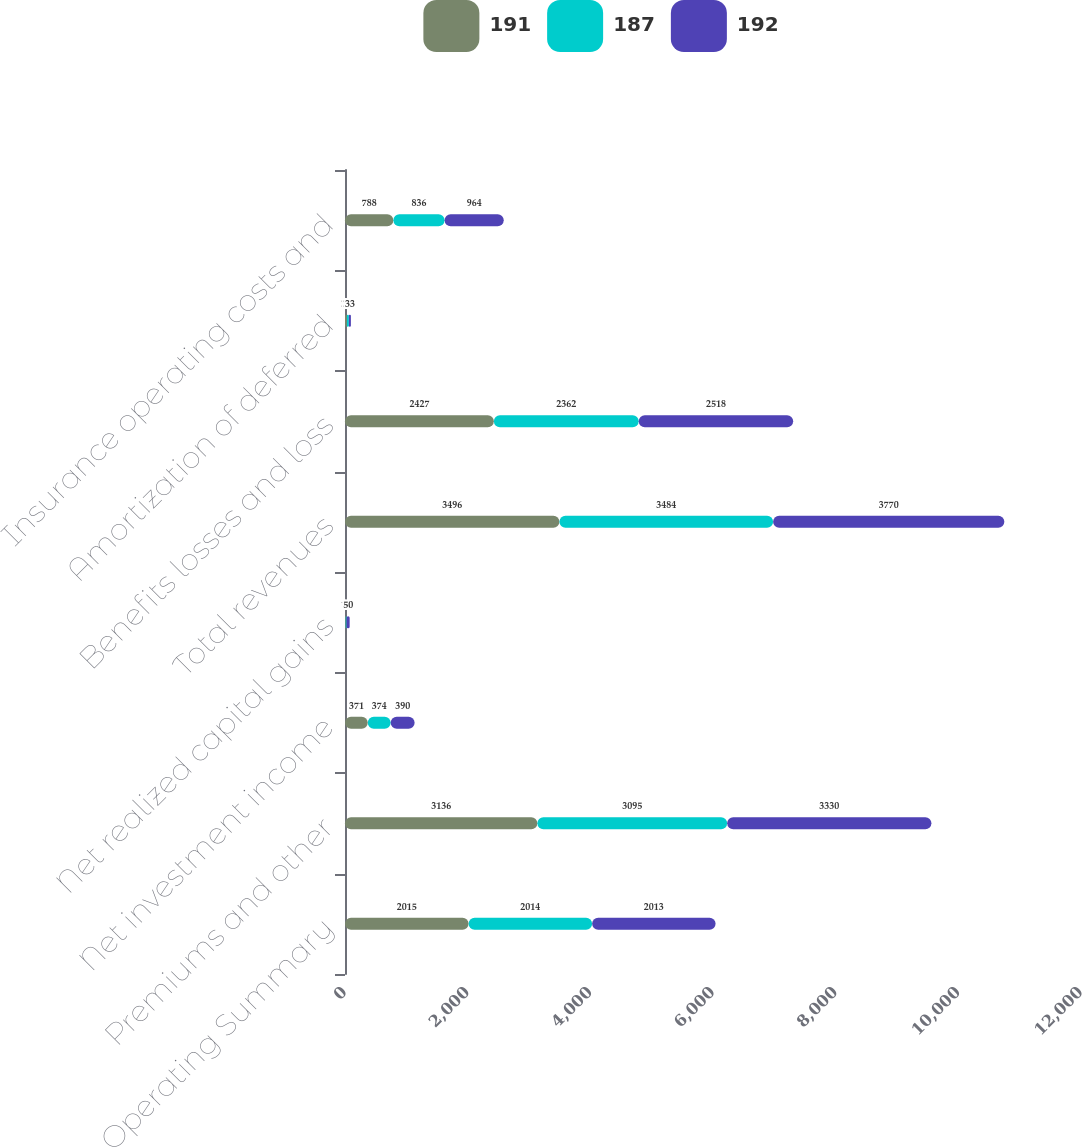Convert chart. <chart><loc_0><loc_0><loc_500><loc_500><stacked_bar_chart><ecel><fcel>Operating Summary<fcel>Premiums and other<fcel>Net investment income<fcel>Net realized capital gains<fcel>Total revenues<fcel>Benefits losses and loss<fcel>Amortization of deferred<fcel>Insurance operating costs and<nl><fcel>191<fcel>2015<fcel>3136<fcel>371<fcel>11<fcel>3496<fcel>2427<fcel>31<fcel>788<nl><fcel>187<fcel>2014<fcel>3095<fcel>374<fcel>15<fcel>3484<fcel>2362<fcel>32<fcel>836<nl><fcel>192<fcel>2013<fcel>3330<fcel>390<fcel>50<fcel>3770<fcel>2518<fcel>33<fcel>964<nl></chart> 